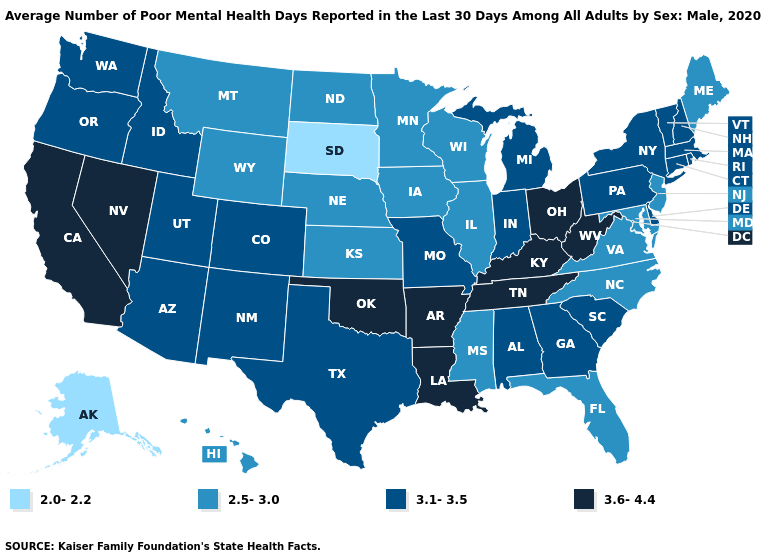Name the states that have a value in the range 2.5-3.0?
Quick response, please. Florida, Hawaii, Illinois, Iowa, Kansas, Maine, Maryland, Minnesota, Mississippi, Montana, Nebraska, New Jersey, North Carolina, North Dakota, Virginia, Wisconsin, Wyoming. What is the value of Arizona?
Keep it brief. 3.1-3.5. What is the value of Delaware?
Answer briefly. 3.1-3.5. Name the states that have a value in the range 2.5-3.0?
Keep it brief. Florida, Hawaii, Illinois, Iowa, Kansas, Maine, Maryland, Minnesota, Mississippi, Montana, Nebraska, New Jersey, North Carolina, North Dakota, Virginia, Wisconsin, Wyoming. What is the lowest value in the USA?
Answer briefly. 2.0-2.2. Name the states that have a value in the range 2.0-2.2?
Give a very brief answer. Alaska, South Dakota. What is the lowest value in the South?
Short answer required. 2.5-3.0. Does Hawaii have the same value as New Jersey?
Answer briefly. Yes. What is the highest value in the USA?
Keep it brief. 3.6-4.4. Among the states that border Alabama , which have the lowest value?
Keep it brief. Florida, Mississippi. Name the states that have a value in the range 2.0-2.2?
Concise answer only. Alaska, South Dakota. Name the states that have a value in the range 3.1-3.5?
Quick response, please. Alabama, Arizona, Colorado, Connecticut, Delaware, Georgia, Idaho, Indiana, Massachusetts, Michigan, Missouri, New Hampshire, New Mexico, New York, Oregon, Pennsylvania, Rhode Island, South Carolina, Texas, Utah, Vermont, Washington. Name the states that have a value in the range 3.1-3.5?
Quick response, please. Alabama, Arizona, Colorado, Connecticut, Delaware, Georgia, Idaho, Indiana, Massachusetts, Michigan, Missouri, New Hampshire, New Mexico, New York, Oregon, Pennsylvania, Rhode Island, South Carolina, Texas, Utah, Vermont, Washington. What is the highest value in the USA?
Give a very brief answer. 3.6-4.4. 